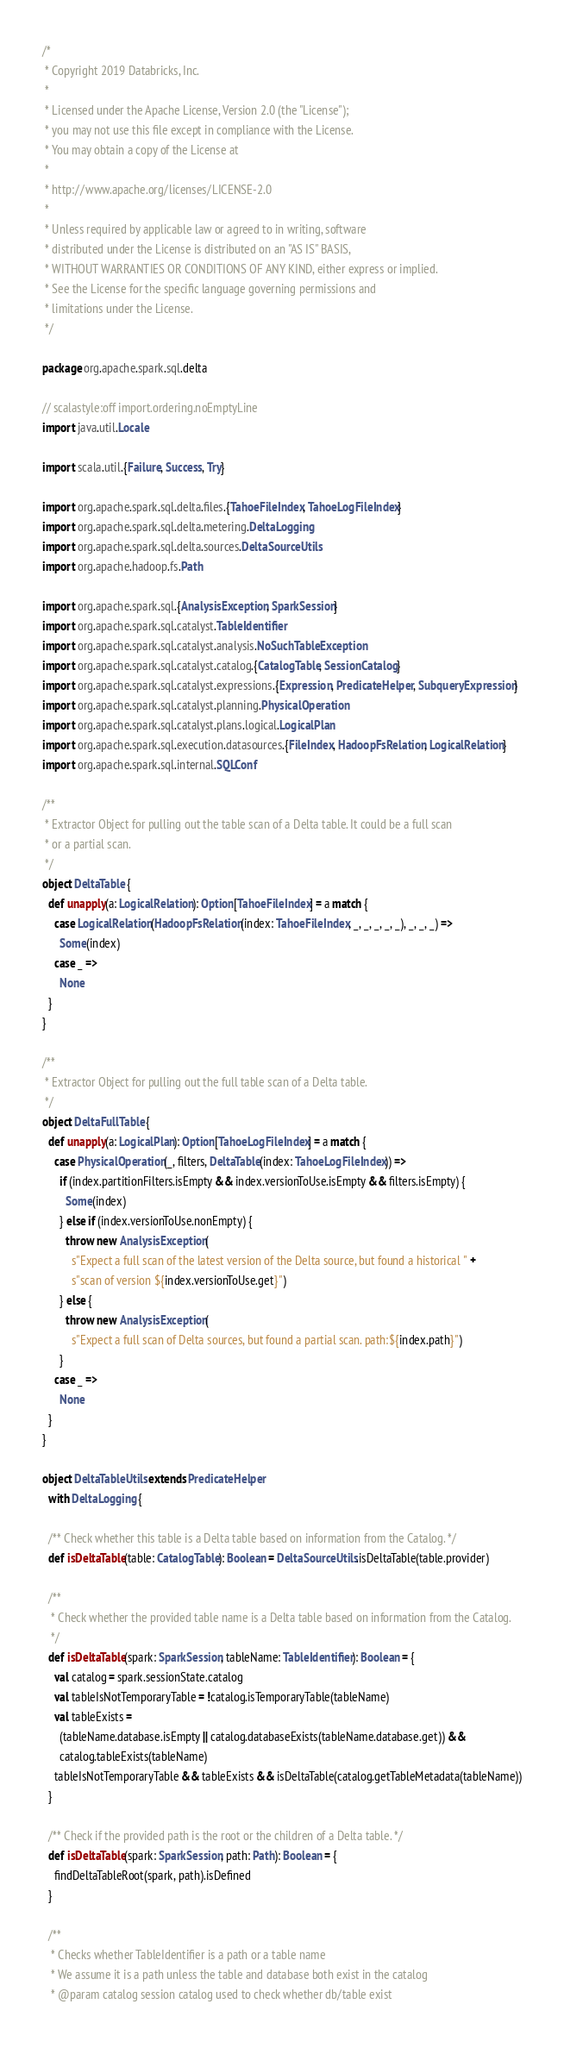Convert code to text. <code><loc_0><loc_0><loc_500><loc_500><_Scala_>/*
 * Copyright 2019 Databricks, Inc.
 *
 * Licensed under the Apache License, Version 2.0 (the "License");
 * you may not use this file except in compliance with the License.
 * You may obtain a copy of the License at
 *
 * http://www.apache.org/licenses/LICENSE-2.0
 *
 * Unless required by applicable law or agreed to in writing, software
 * distributed under the License is distributed on an "AS IS" BASIS,
 * WITHOUT WARRANTIES OR CONDITIONS OF ANY KIND, either express or implied.
 * See the License for the specific language governing permissions and
 * limitations under the License.
 */

package org.apache.spark.sql.delta

// scalastyle:off import.ordering.noEmptyLine
import java.util.Locale

import scala.util.{Failure, Success, Try}

import org.apache.spark.sql.delta.files.{TahoeFileIndex, TahoeLogFileIndex}
import org.apache.spark.sql.delta.metering.DeltaLogging
import org.apache.spark.sql.delta.sources.DeltaSourceUtils
import org.apache.hadoop.fs.Path

import org.apache.spark.sql.{AnalysisException, SparkSession}
import org.apache.spark.sql.catalyst.TableIdentifier
import org.apache.spark.sql.catalyst.analysis.NoSuchTableException
import org.apache.spark.sql.catalyst.catalog.{CatalogTable, SessionCatalog}
import org.apache.spark.sql.catalyst.expressions.{Expression, PredicateHelper, SubqueryExpression}
import org.apache.spark.sql.catalyst.planning.PhysicalOperation
import org.apache.spark.sql.catalyst.plans.logical.LogicalPlan
import org.apache.spark.sql.execution.datasources.{FileIndex, HadoopFsRelation, LogicalRelation}
import org.apache.spark.sql.internal.SQLConf

/**
 * Extractor Object for pulling out the table scan of a Delta table. It could be a full scan
 * or a partial scan.
 */
object DeltaTable {
  def unapply(a: LogicalRelation): Option[TahoeFileIndex] = a match {
    case LogicalRelation(HadoopFsRelation(index: TahoeFileIndex, _, _, _, _, _), _, _, _) =>
      Some(index)
    case _ =>
      None
  }
}

/**
 * Extractor Object for pulling out the full table scan of a Delta table.
 */
object DeltaFullTable {
  def unapply(a: LogicalPlan): Option[TahoeLogFileIndex] = a match {
    case PhysicalOperation(_, filters, DeltaTable(index: TahoeLogFileIndex)) =>
      if (index.partitionFilters.isEmpty && index.versionToUse.isEmpty && filters.isEmpty) {
        Some(index)
      } else if (index.versionToUse.nonEmpty) {
        throw new AnalysisException(
          s"Expect a full scan of the latest version of the Delta source, but found a historical " +
          s"scan of version ${index.versionToUse.get}")
      } else {
        throw new AnalysisException(
          s"Expect a full scan of Delta sources, but found a partial scan. path:${index.path}")
      }
    case _ =>
      None
  }
}

object DeltaTableUtils extends PredicateHelper
  with DeltaLogging {

  /** Check whether this table is a Delta table based on information from the Catalog. */
  def isDeltaTable(table: CatalogTable): Boolean = DeltaSourceUtils.isDeltaTable(table.provider)

  /**
   * Check whether the provided table name is a Delta table based on information from the Catalog.
   */
  def isDeltaTable(spark: SparkSession, tableName: TableIdentifier): Boolean = {
    val catalog = spark.sessionState.catalog
    val tableIsNotTemporaryTable = !catalog.isTemporaryTable(tableName)
    val tableExists =
      (tableName.database.isEmpty || catalog.databaseExists(tableName.database.get)) &&
      catalog.tableExists(tableName)
    tableIsNotTemporaryTable && tableExists && isDeltaTable(catalog.getTableMetadata(tableName))
  }

  /** Check if the provided path is the root or the children of a Delta table. */
  def isDeltaTable(spark: SparkSession, path: Path): Boolean = {
    findDeltaTableRoot(spark, path).isDefined
  }

  /**
   * Checks whether TableIdentifier is a path or a table name
   * We assume it is a path unless the table and database both exist in the catalog
   * @param catalog session catalog used to check whether db/table exist</code> 